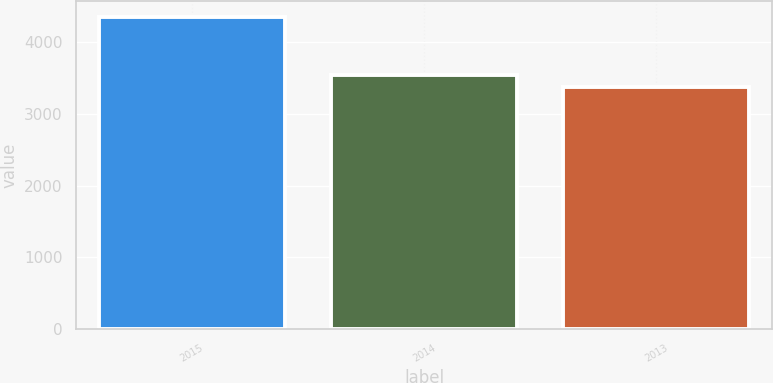Convert chart. <chart><loc_0><loc_0><loc_500><loc_500><bar_chart><fcel>2015<fcel>2014<fcel>2013<nl><fcel>4347<fcel>3533<fcel>3375<nl></chart> 